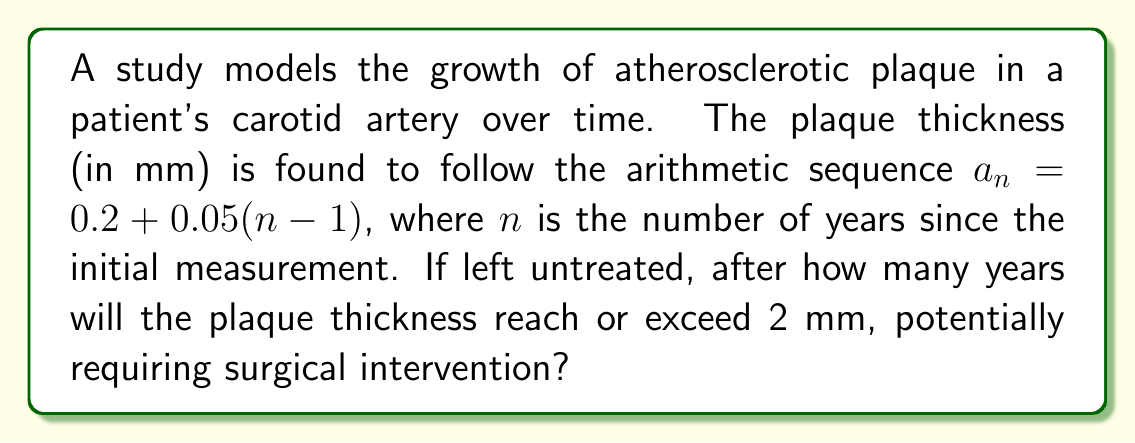Can you solve this math problem? Let's approach this step-by-step:

1) The arithmetic sequence is given by $a_n = 0.2 + 0.05(n-1)$, where:
   - $a_n$ is the plaque thickness in mm
   - $n$ is the number of years since initial measurement
   - 0.2 mm is the initial thickness
   - 0.05 mm is the yearly increase

2) We need to find $n$ when $a_n \geq 2$ mm:

   $$0.2 + 0.05(n-1) \geq 2$$

3) Solve the inequality:
   $$0.2 + 0.05n - 0.05 \geq 2$$
   $$0.05n + 0.15 \geq 2$$
   $$0.05n \geq 1.85$$
   $$n \geq \frac{1.85}{0.05} = 37$$

4) Since $n$ represents years and must be a whole number, we round up to the next integer.

5) Therefore, the plaque thickness will reach or exceed 2 mm after 37 years.
Answer: 37 years 